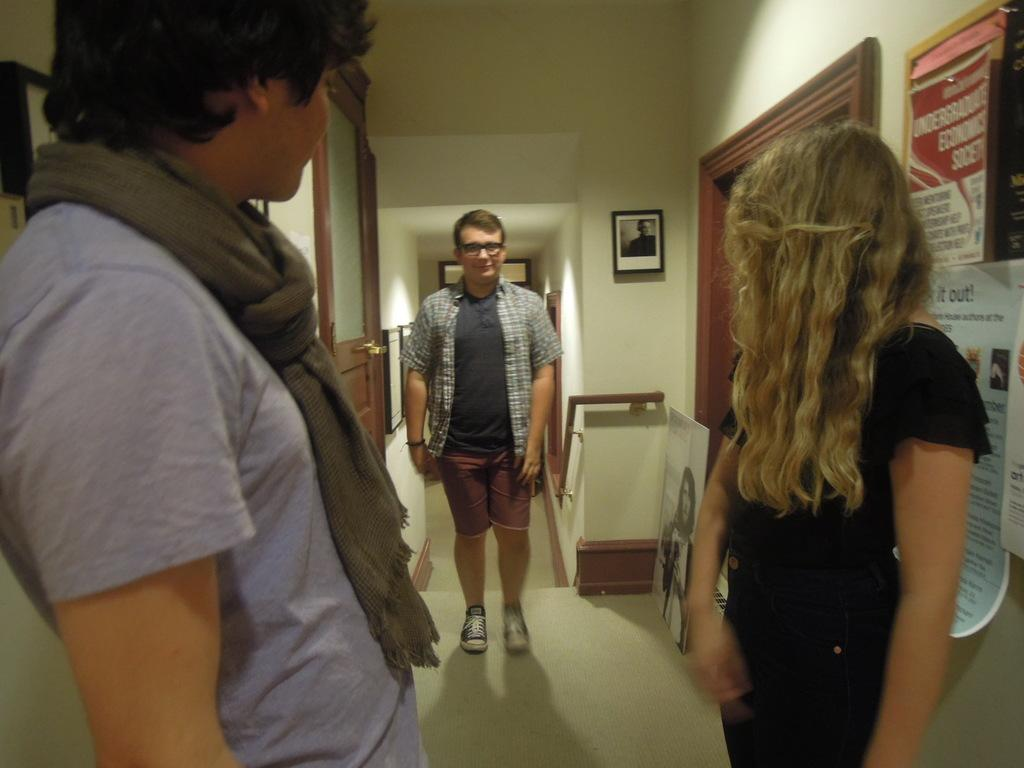How many people are present in the image? There are three people in the image. What can be seen on the wall in the image? There are pictures and posters on the wall. Where is the door located in relation to the people? There is a door beside one of the people. What is the image of a woman doing in the image? There is a picture of a woman on the floor. What type of spoon is being used to hit the baseball in the image? There is no spoon or baseball present in the image. 